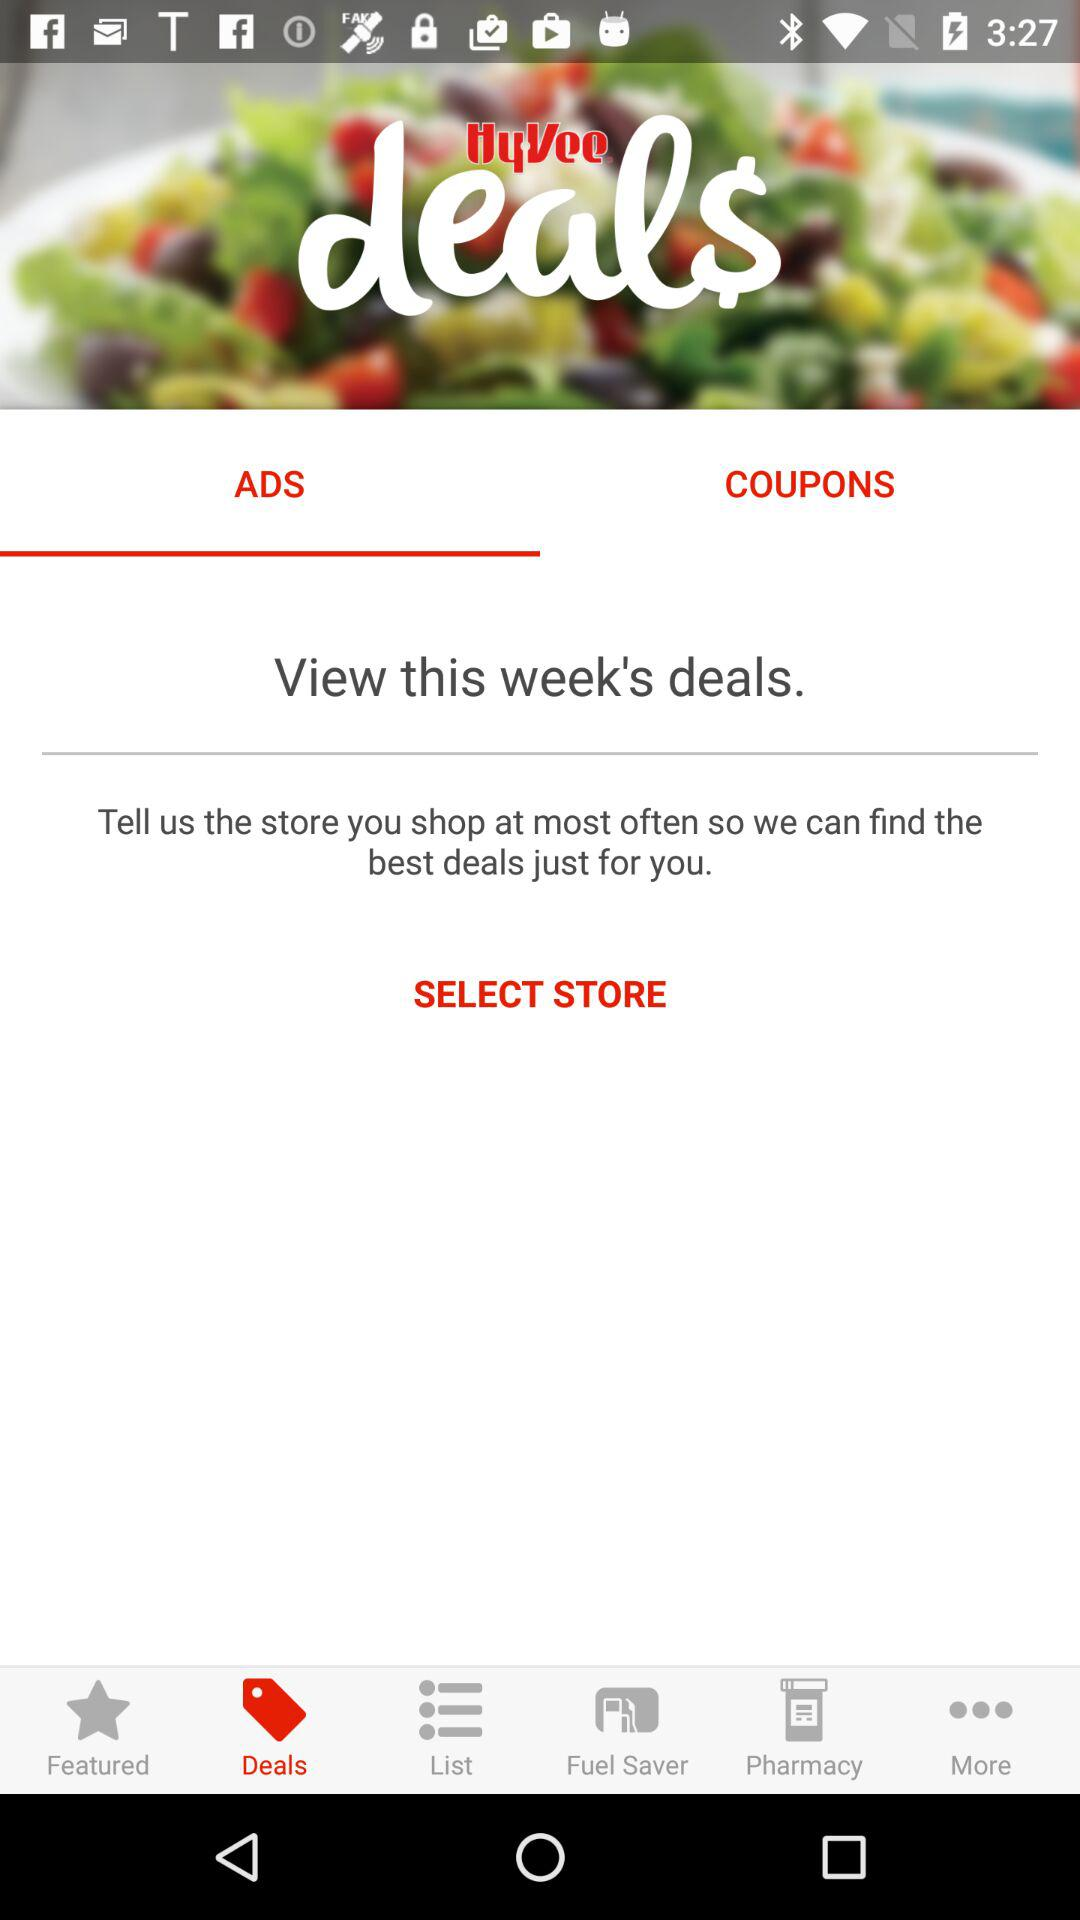Which is the selected tab? The selected tab is "ADS". 